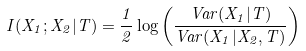<formula> <loc_0><loc_0><loc_500><loc_500>I ( X _ { 1 } ; X _ { 2 } | T ) = \frac { 1 } { 2 } \log \left ( \frac { V a r ( X _ { 1 } | T ) } { V a r ( X _ { 1 } | X _ { 2 } , T ) } \right )</formula> 